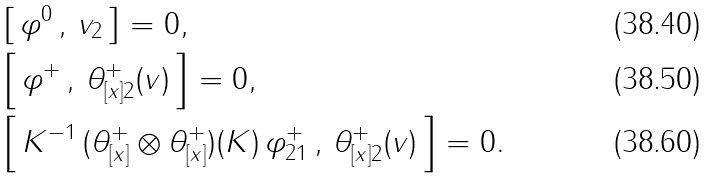Convert formula to latex. <formula><loc_0><loc_0><loc_500><loc_500>& \left [ \, \varphi ^ { 0 } \, , \, v _ { 2 } \, \right ] = 0 , \\ & \left [ \, \varphi ^ { + } \, , \, \theta _ { [ x ] 2 } ^ { + } ( v ) \, \right ] = 0 , \\ & \left [ \, K ^ { - 1 } \, ( \theta ^ { + } _ { [ x ] } \otimes \theta ^ { + } _ { [ x ] } ) ( K ) \, \varphi _ { 2 1 } ^ { + } \, , \, \theta _ { [ x ] 2 } ^ { + } ( v ) \, \right ] = 0 .</formula> 